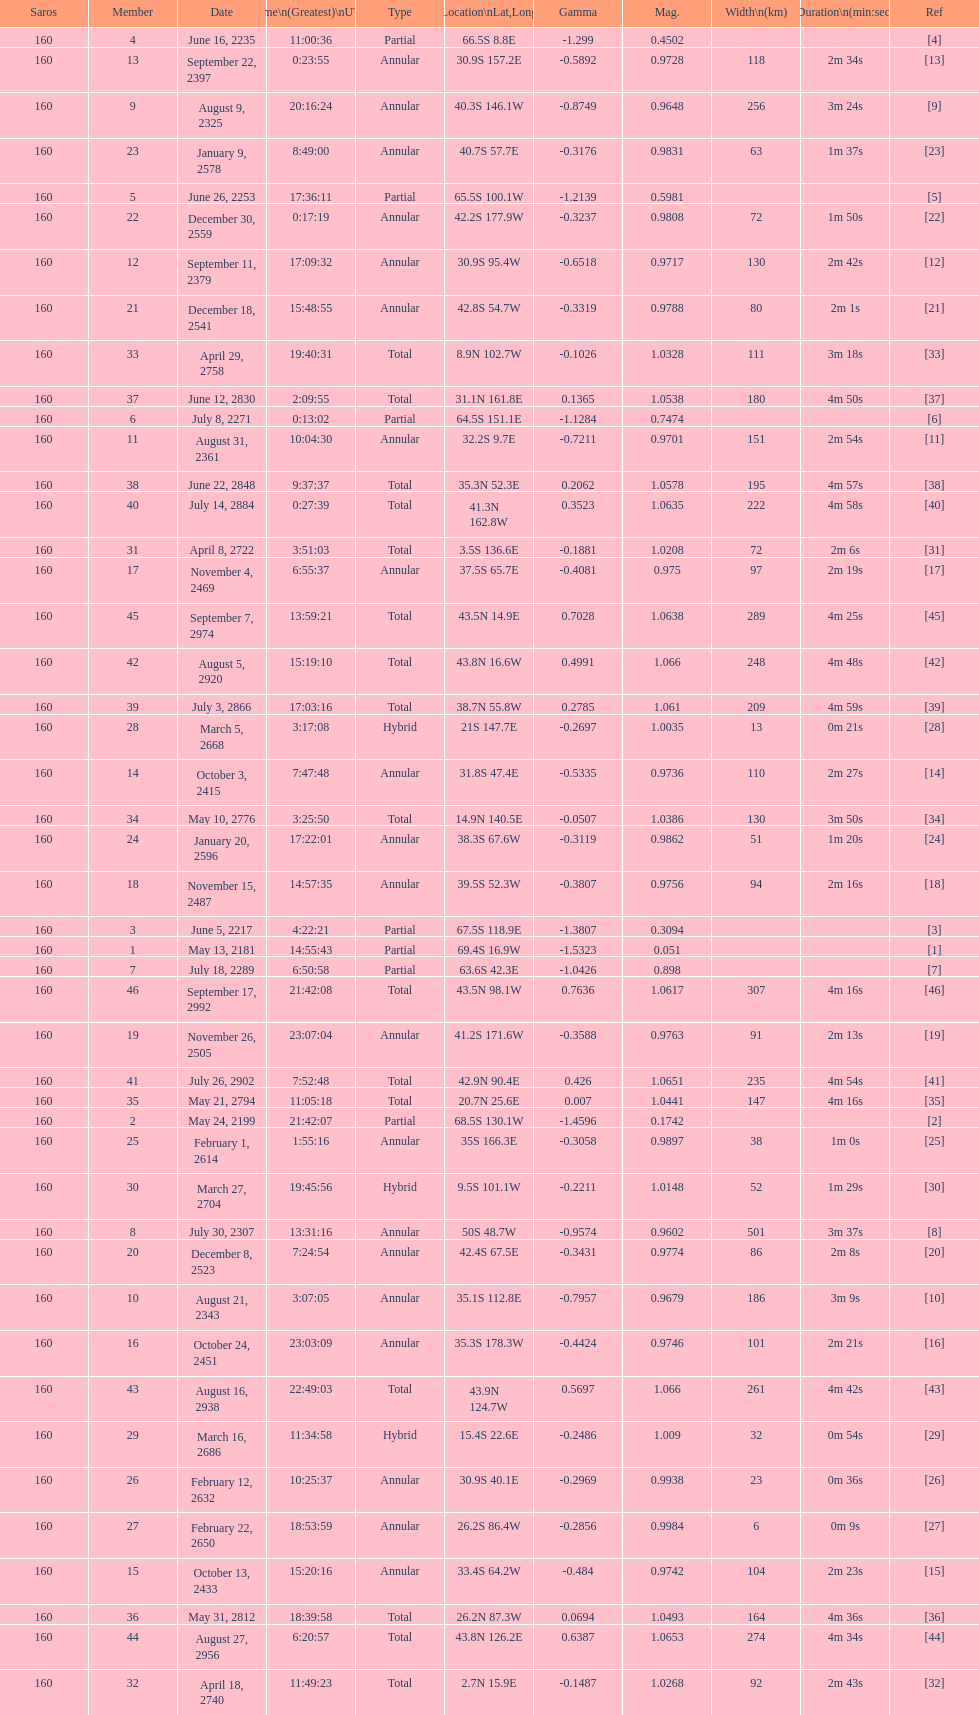How many solar saros events lasted longer than 4 minutes? 12. 